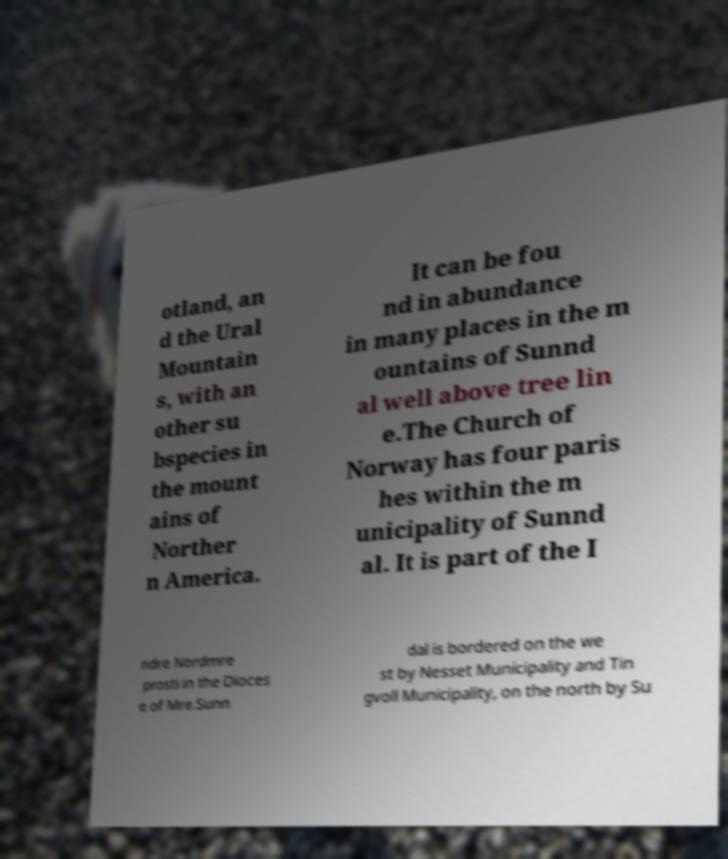I need the written content from this picture converted into text. Can you do that? otland, an d the Ural Mountain s, with an other su bspecies in the mount ains of Norther n America. It can be fou nd in abundance in many places in the m ountains of Sunnd al well above tree lin e.The Church of Norway has four paris hes within the m unicipality of Sunnd al. It is part of the I ndre Nordmre prosti in the Dioces e of Mre.Sunn dal is bordered on the we st by Nesset Municipality and Tin gvoll Municipality, on the north by Su 